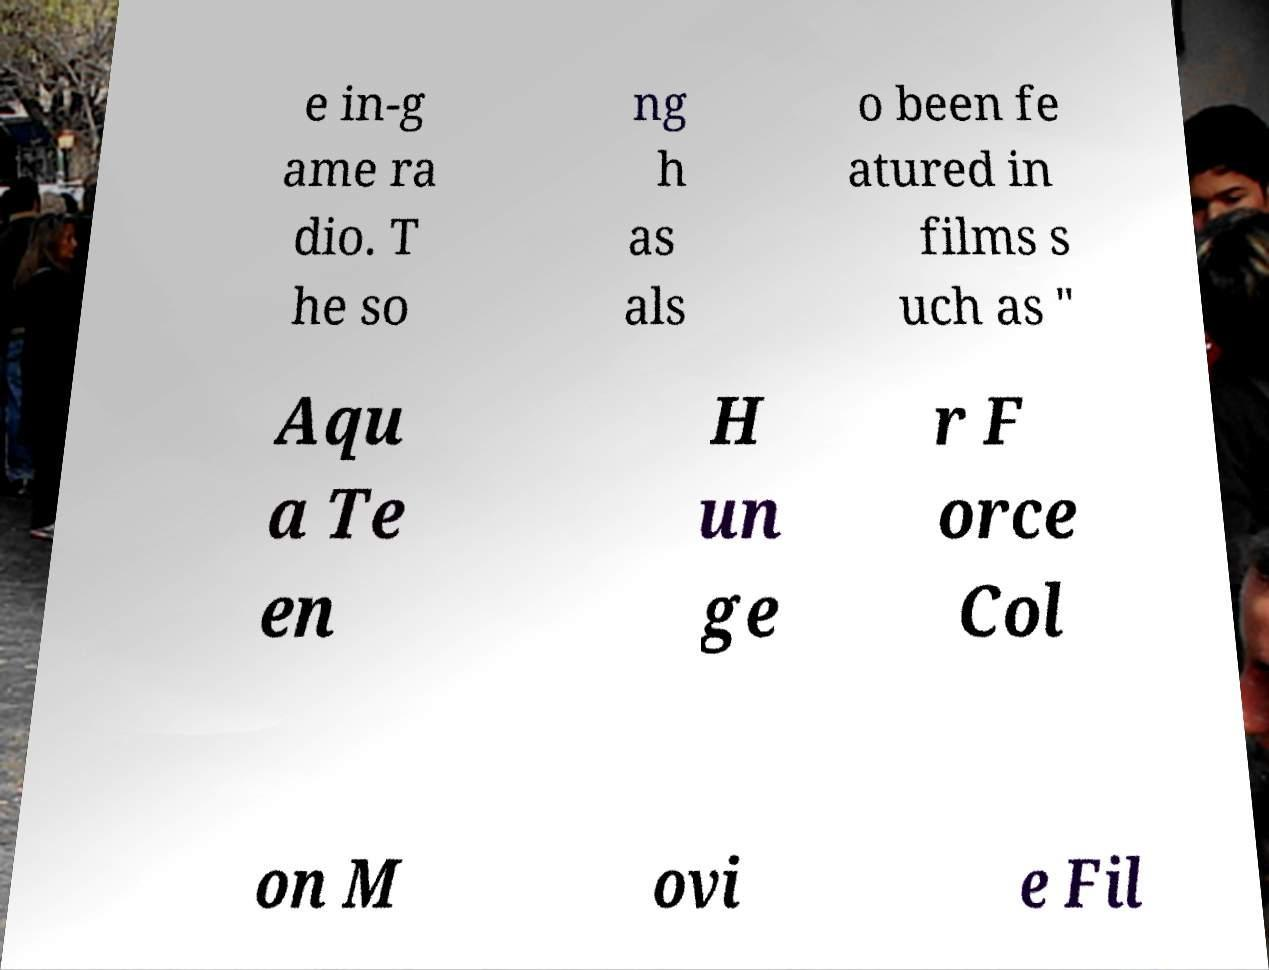Could you extract and type out the text from this image? e in-g ame ra dio. T he so ng h as als o been fe atured in films s uch as " Aqu a Te en H un ge r F orce Col on M ovi e Fil 